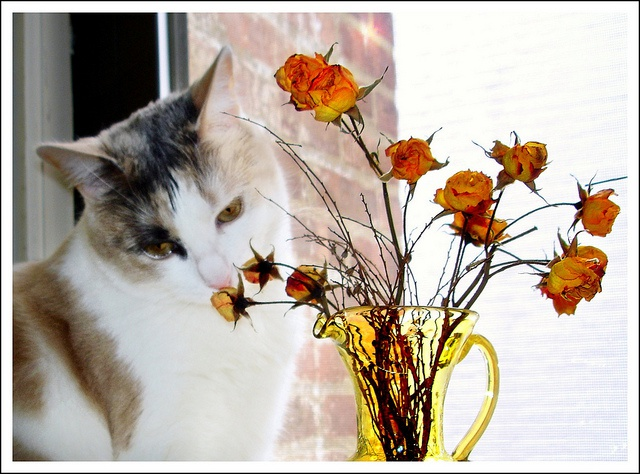Describe the objects in this image and their specific colors. I can see cat in black, lightgray, darkgray, and gray tones and vase in black, white, khaki, and maroon tones in this image. 